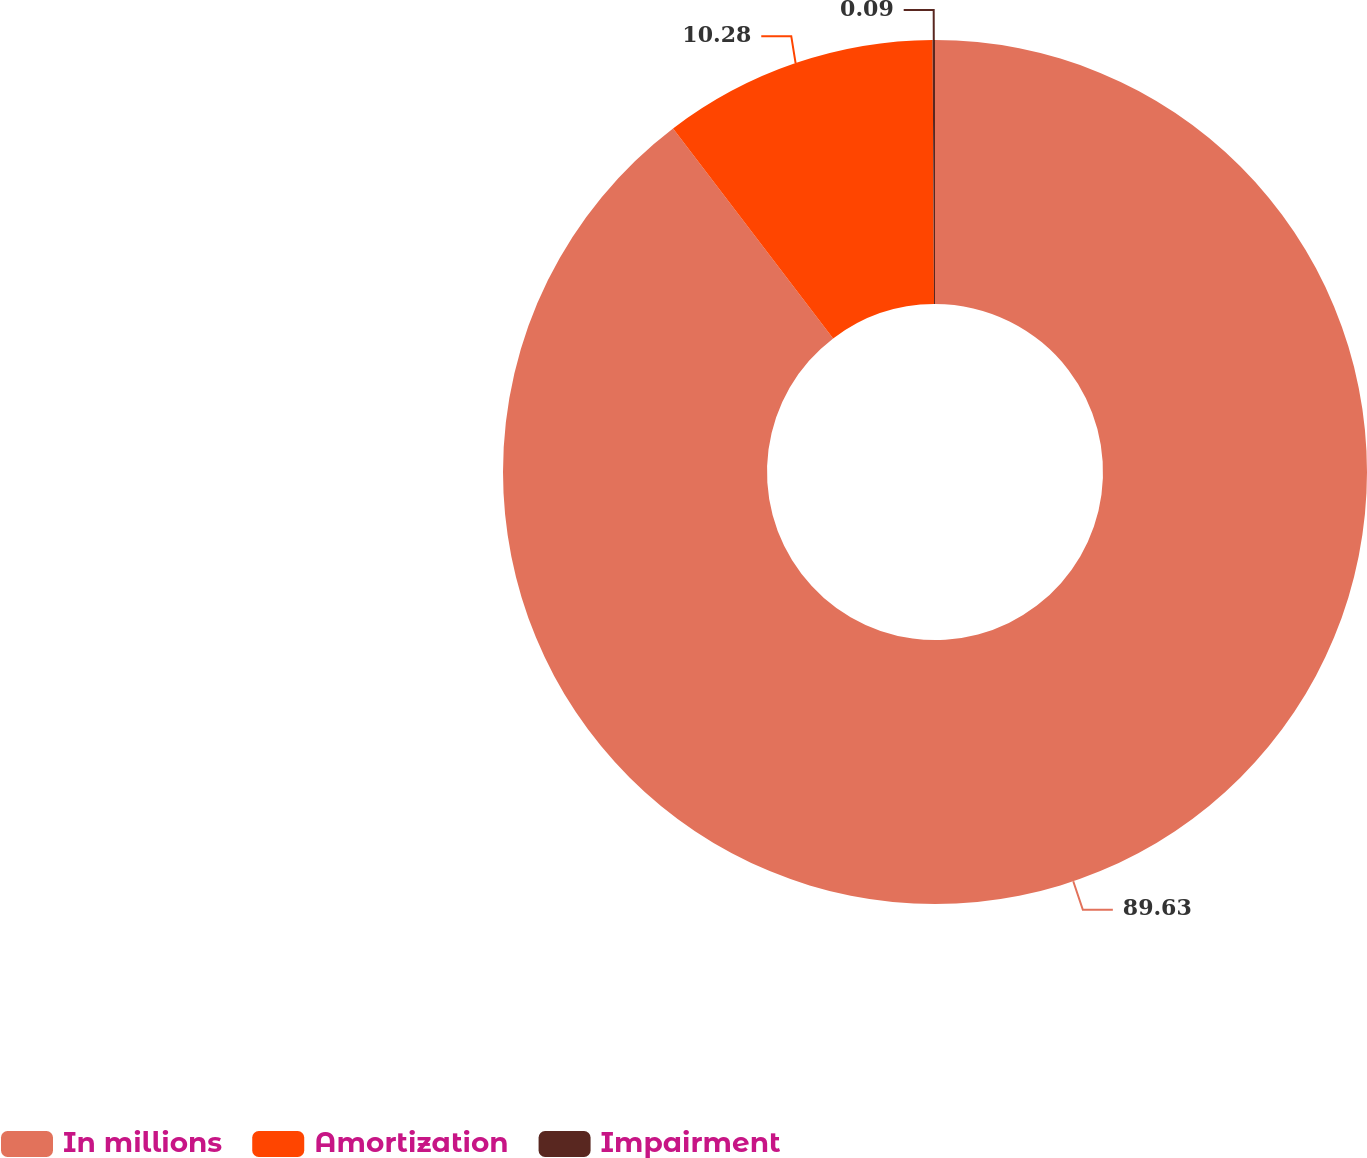<chart> <loc_0><loc_0><loc_500><loc_500><pie_chart><fcel>In millions<fcel>Amortization<fcel>Impairment<nl><fcel>89.64%<fcel>10.28%<fcel>0.09%<nl></chart> 